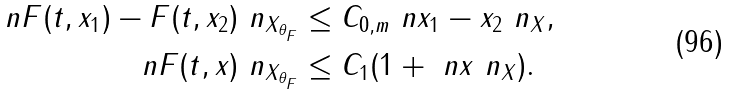Convert formula to latex. <formula><loc_0><loc_0><loc_500><loc_500>\ n F ( t , x _ { 1 } ) - F ( t , x _ { 2 } ) \ n _ { X _ { \theta _ { F } } } & \leq C _ { 0 , m } \ n x _ { 1 } - x _ { 2 } \ n _ { X } , \\ \ n F ( t , x ) \ n _ { X _ { \theta _ { F } } } & \leq C _ { 1 } ( 1 + \ n x \ n _ { X } ) .</formula> 